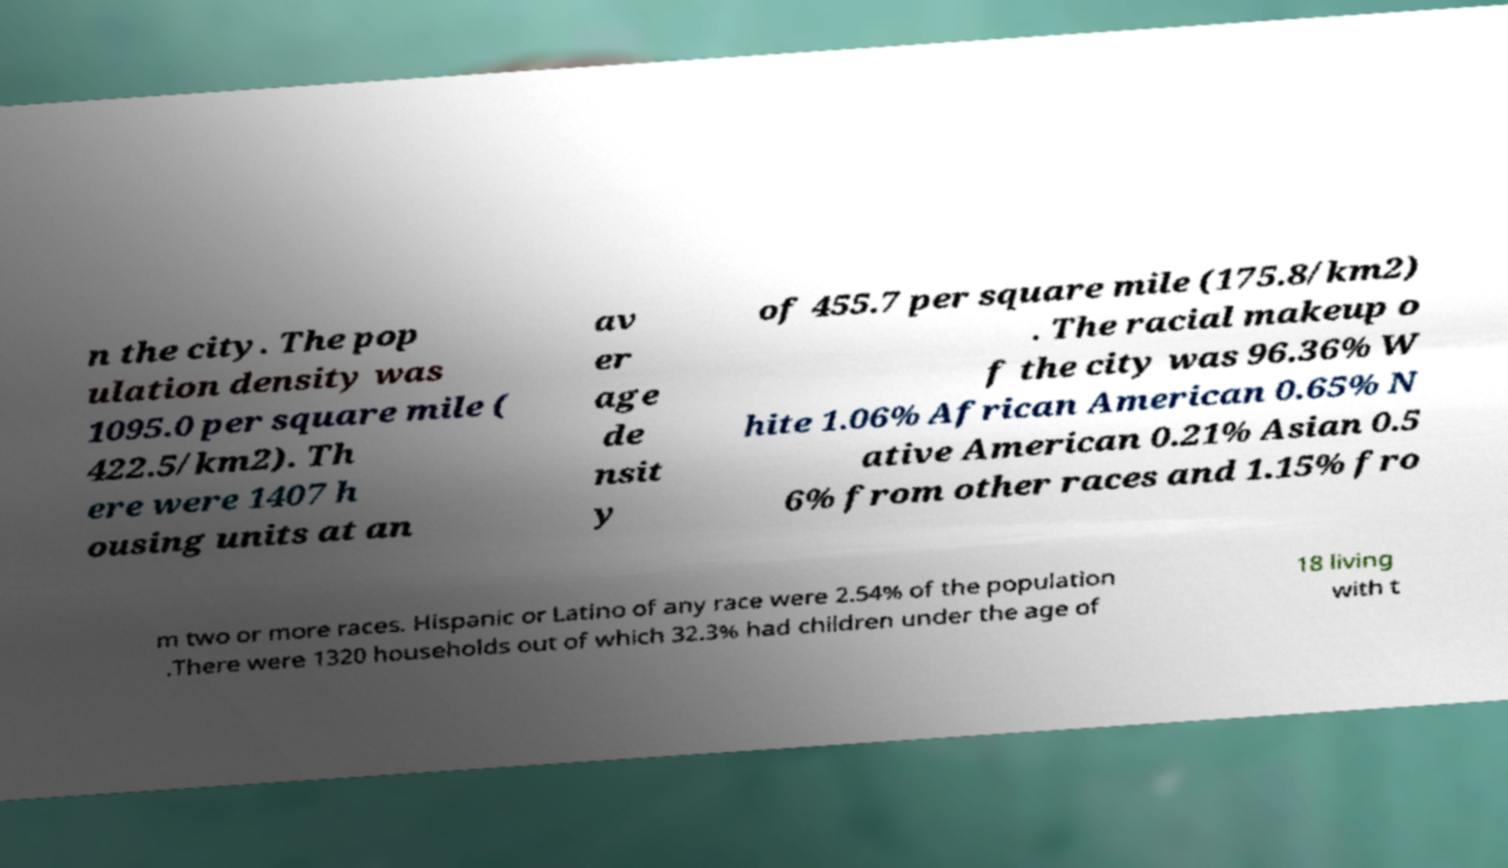I need the written content from this picture converted into text. Can you do that? n the city. The pop ulation density was 1095.0 per square mile ( 422.5/km2). Th ere were 1407 h ousing units at an av er age de nsit y of 455.7 per square mile (175.8/km2) . The racial makeup o f the city was 96.36% W hite 1.06% African American 0.65% N ative American 0.21% Asian 0.5 6% from other races and 1.15% fro m two or more races. Hispanic or Latino of any race were 2.54% of the population .There were 1320 households out of which 32.3% had children under the age of 18 living with t 